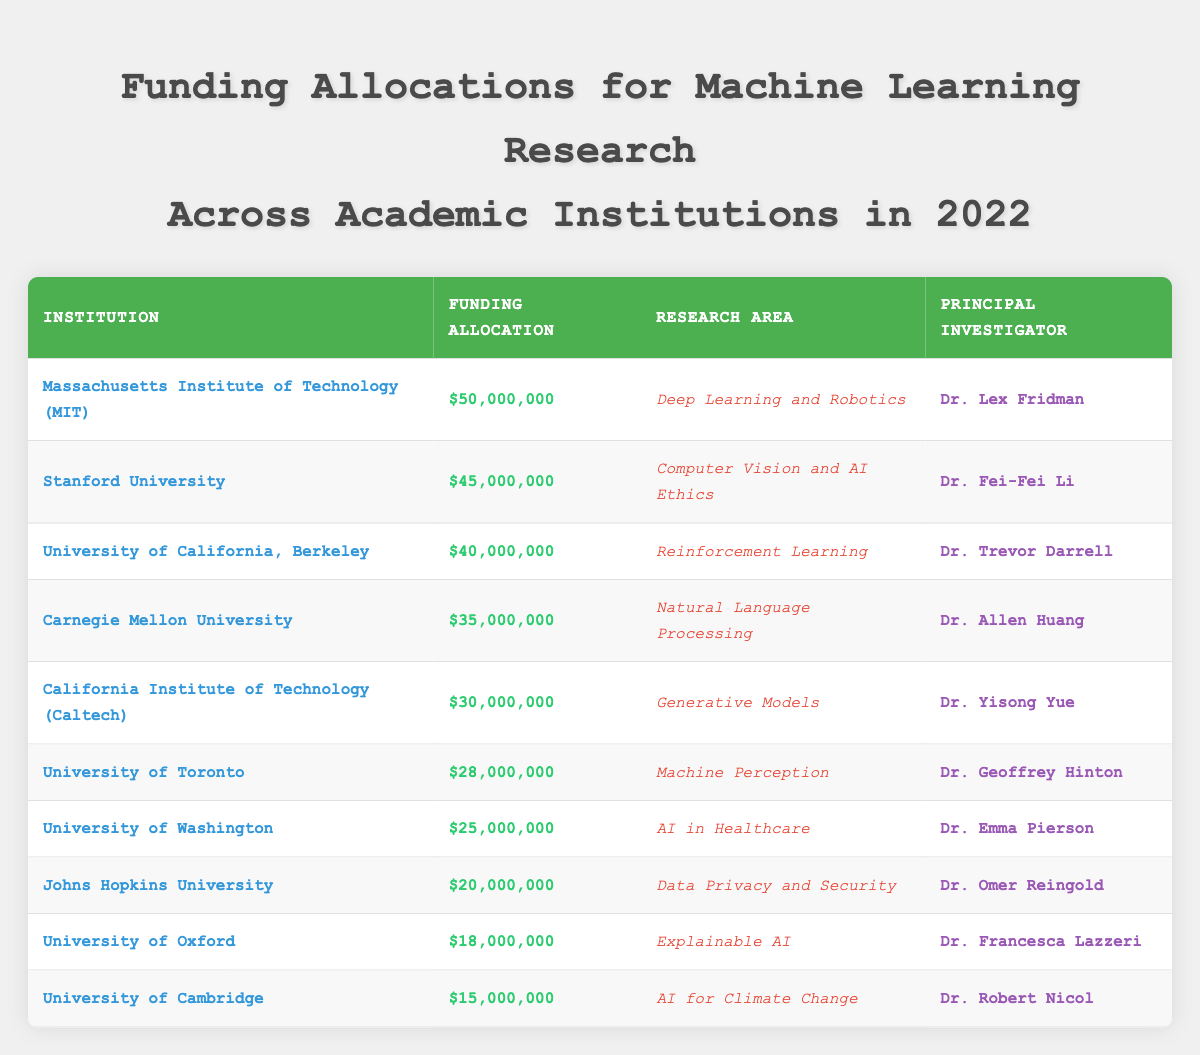What is the total funding allocated for machine learning research among these institutions? To find the total funding, we sum up the funding allocations from each institution: $50,000,000 + $45,000,000 + $40,000,000 + $35,000,000 + $30,000,000 + $28,000,000 + $25,000,000 + $20,000,000 + $18,000,000 + $15,000,000 = $386,000,000
Answer: $386,000,000 Which institution received the highest funding allocation? Looking at the funding allocations, the highest value is $50,000,000 which corresponds to the Massachusetts Institute of Technology (MIT)
Answer: Massachusetts Institute of Technology (MIT) How much funding did University of Washington receive? The table shows that the University of Washington received a funding allocation of $25,000,000
Answer: $25,000,000 Which research area received the least amount of funding? By checking the funding allocations, the least funding is $15,000,000 for the research area "AI for Climate Change" at the University of Cambridge
Answer: AI for Climate Change Is there any institution that received more than $30,000,000? By examining the funding allocations, we can see that MIT ($50,000,000), Stanford ($45,000,000), UC Berkeley ($40,000,000), Carnegie Mellon ($35,000,000), and Caltech ($30,000,000) all received more than $30,000,000
Answer: Yes What is the average funding allocation for institutions listed in the table? There are 10 institutions. The total funding is $386,000,000. To find the average, we divide the total by the number of institutions: $386,000,000 / 10 = $38,600,000
Answer: $38,600,000 Which principal investigator is associated with the research area of "Natural Language Processing"? Referring to the table, the principal investigator associated with "Natural Language Processing" is Dr. Allen Huang from Carnegie Mellon University
Answer: Dr. Allen Huang How much more funding did MIT receive compared to the University of Cambridge? MIT's funding is $50,000,000 and the University of Cambridge's funding is $15,000,000. The difference is $50,000,000 - $15,000,000 = $35,000,000
Answer: $35,000,000 Which institutions focus on AI ethics or explainable AI? Reviewing the table, Stanford University focuses on "Computer Vision and AI Ethics," and University of Oxford focuses on "Explainable AI"
Answer: Stanford University and University of Oxford If we combine the funding of the top three institutions, what is the total? The top three institutions are MIT ($50,000,000), Stanford ($45,000,000), and UC Berkeley ($40,000,000). Their combined funding is $50,000,000 + $45,000,000 + $40,000,000 = $135,000,000
Answer: $135,000,000 Which research areas received funding between $20,000,000 and $30,000,000? Checking the funding amounts, the research areas that fall within this range are: AI in Healthcare ($25,000,000), and Generative Models ($30,000,000)
Answer: AI in Healthcare and Generative Models 